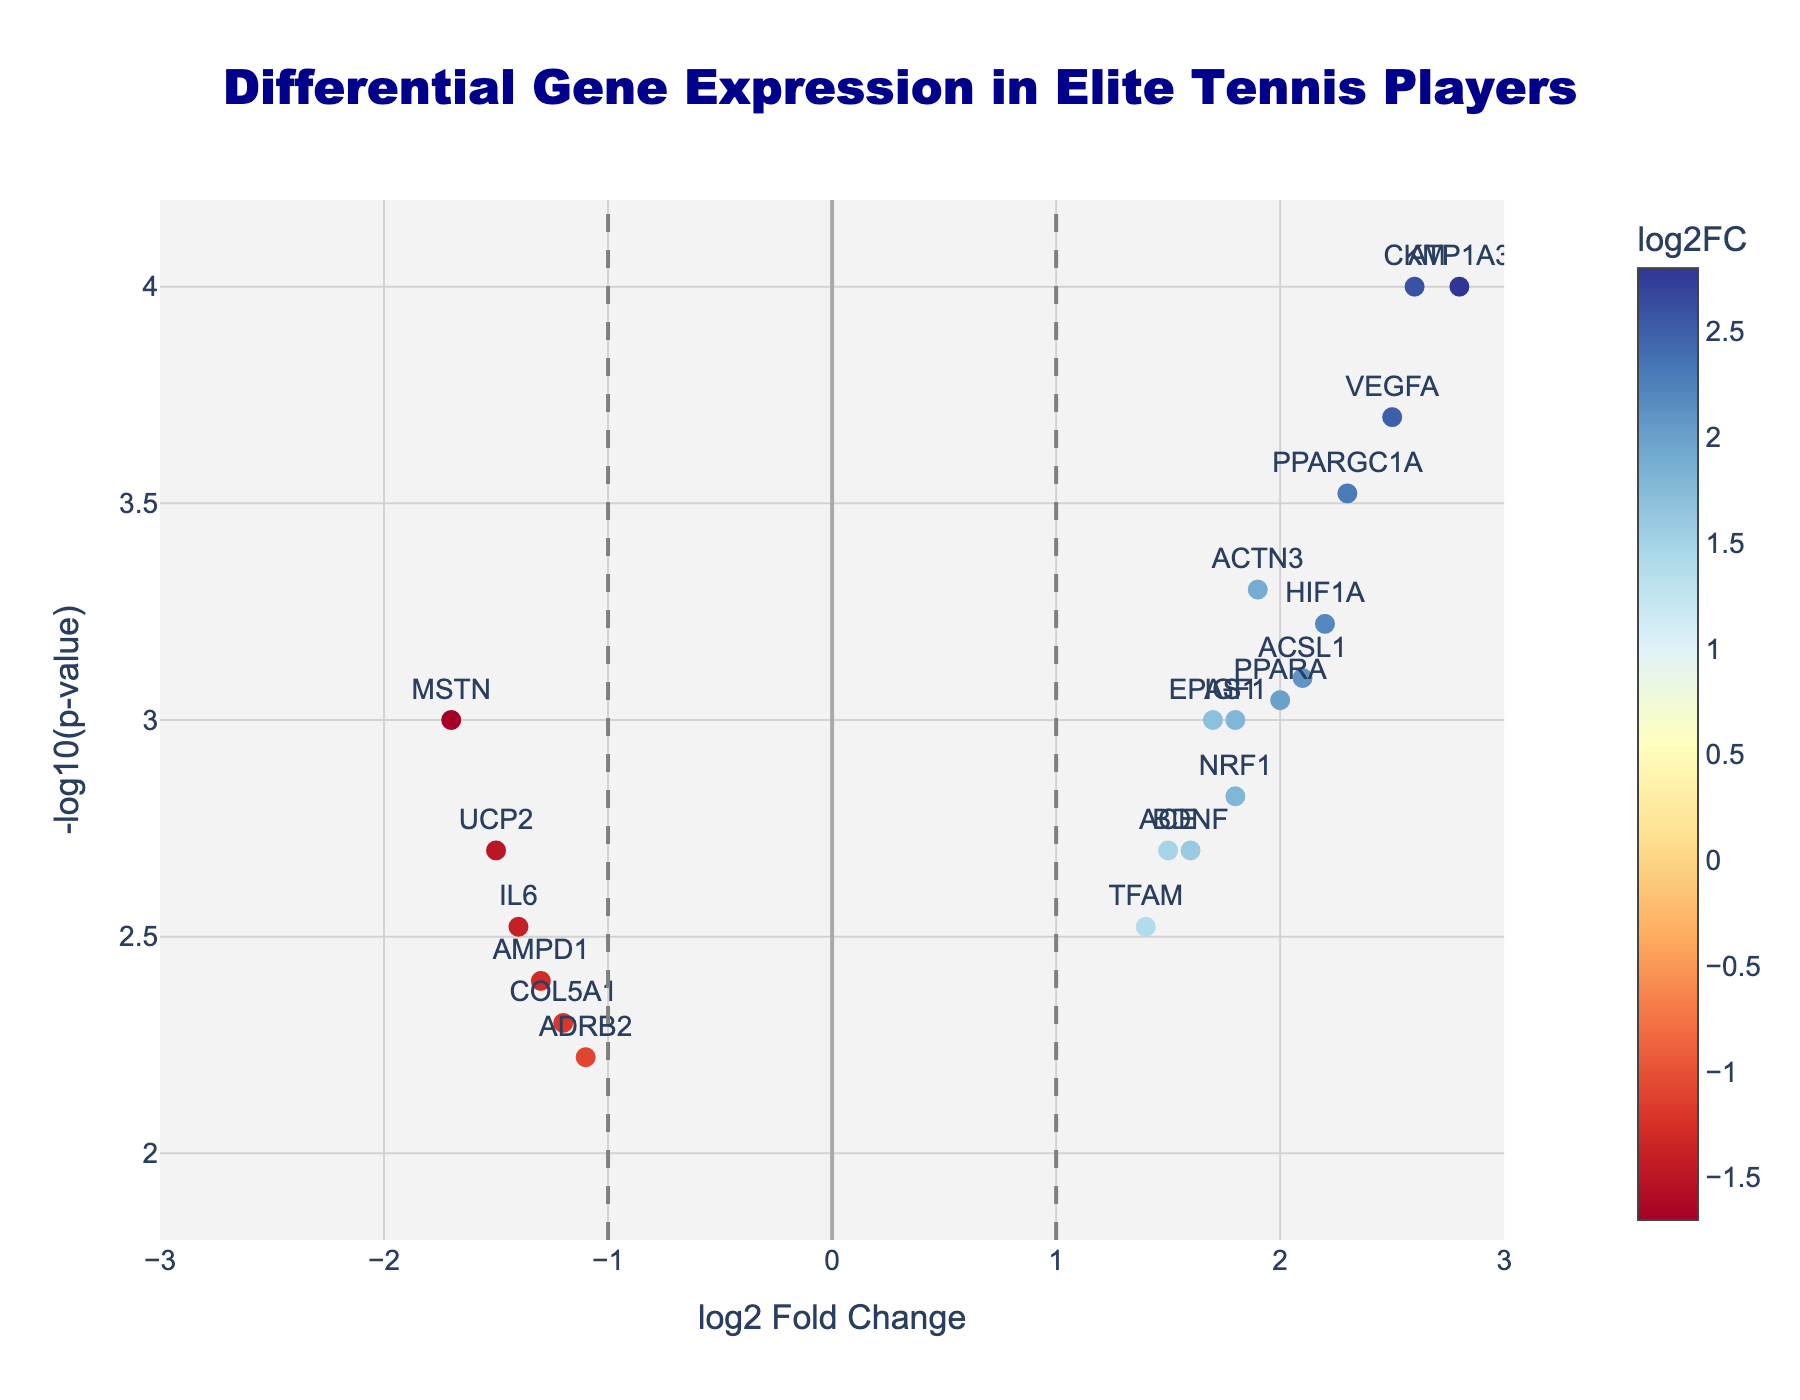Which gene has the highest log2 fold change? To find the highest log2 fold change, identify the data point with the largest x-value on the plot. The gene CKM has the highest log2 fold change of 2.6.
Answer: CKM Which gene has the lowest p-value? The lowest p-value corresponds to the highest -log10(p-value) on the y-axis. The gene with the highest -log10(p-value) is ATP1A3.
Answer: ATP1A3 How many genes have a log2 fold change greater than 1? Identify the genes with x-values greater than 1. This includes ATP1A3, ACTN3, PPARGC1A, ACE, ACSL1, VEGFA, BDNF, HIF1A, CKM, EPAS1, PPARA, IGF1.
Answer: 12 What is the log2 fold change of MSTN? Find MSTN on the plot and read its x-value. The log2 fold change for MSTN is -1.7.
Answer: -1.7 Which gene has the second highest -log10(p-value)? Identify the second highest point on the y-axis, the gene next to ATP1A3 with high -log10(p-value) is CKM.
Answer: CKM What is the p-value of VEGFA? Locate VEGFA on the plot and check the y-value to get -log10(p-value), then convert it back to p-value. VEGFA has a -log10(p-value) of around 3.7, which corresponds to a p-value of approximately 0.0002.
Answer: 0.0002 Which gene has the highest negative log2 fold change? Identify the gene with the largest negative x-value. MSTN has the highest negative log2 fold change of -1.7.
Answer: MSTN How many genes have a p-value less than 0.001? Identify genes with -log10(p-value) greater than 3, as -log10(0.001) is 3. These genes are ATP1A3, ACTN3, PPARGC1A, VEGFA, CKM.
Answer: 5 Compare the log2 fold change of ACE and ADRB2. Which is greater? Locate the points for ACE and ADRB2 and compare their x-values. ACE has a log2 fold change of 1.5 and ADRB2 has -1.1.
Answer: ACE Which horizontal line indicates a threshold for statistical significance, and what is its value? The horizontal dashed line represents the threshold for p-value = 0.05, which is -log10(0.05) ≈ 1.3.
Answer: 1.3 